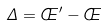Convert formula to latex. <formula><loc_0><loc_0><loc_500><loc_500>\Delta = \phi ^ { \prime } - \phi</formula> 